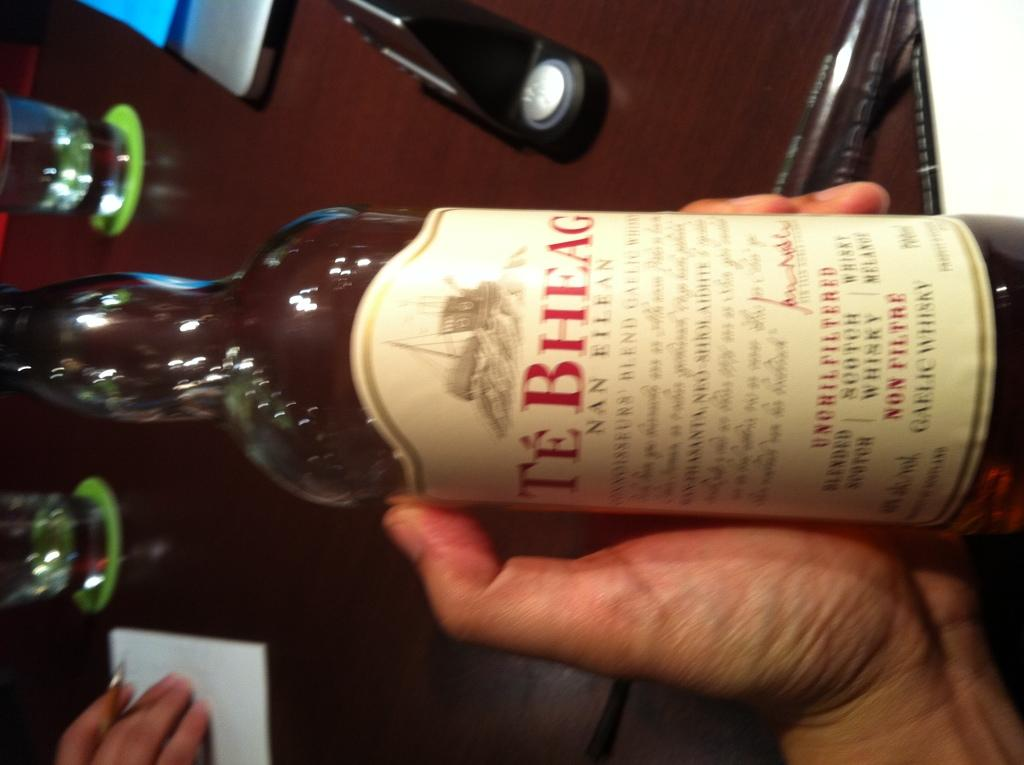What is the person on the left side of the image holding? The person on the left side of the image is holding a bottle. What is the person on the right side of the image holding? The person on the right side of the image is holding a pen and paper. How many glasses can be seen in the image? There are two glasses visible in the image. What month is depicted on the calendar in the image? There is no calendar present in the image, so it is not possible to determine the month. 